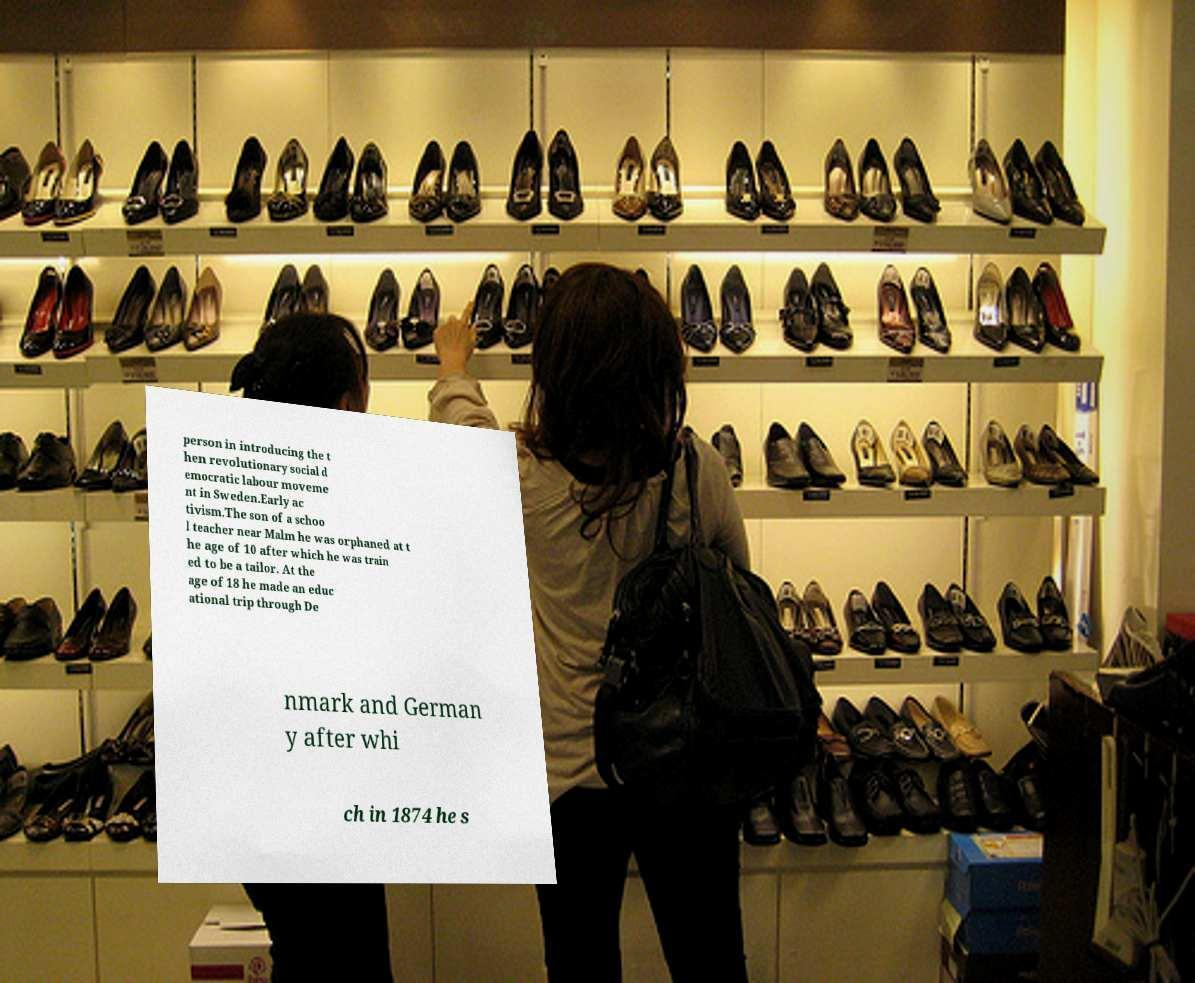There's text embedded in this image that I need extracted. Can you transcribe it verbatim? person in introducing the t hen revolutionary social d emocratic labour moveme nt in Sweden.Early ac tivism.The son of a schoo l teacher near Malm he was orphaned at t he age of 10 after which he was train ed to be a tailor. At the age of 18 he made an educ ational trip through De nmark and German y after whi ch in 1874 he s 